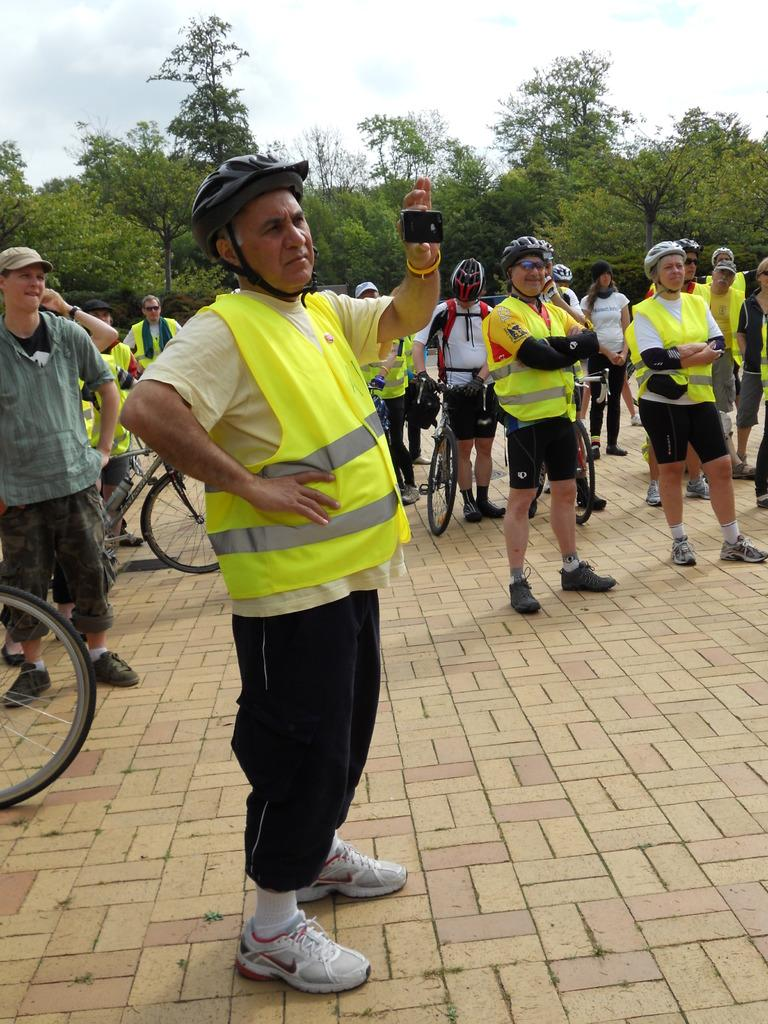What is the main subject of the image? The main subject of the image is a group of people. What can be seen at the top of the image? The sky is visible at the top of the image. What type of vegetation is in the background of the image? There are trees in the background of the image. What type of paste is being used by the farmer in the image? There is no farmer or paste present in the image; it features a group of people and trees in the background. 